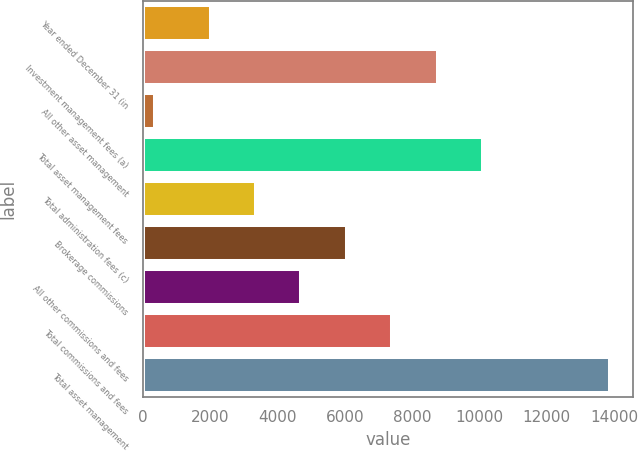<chart> <loc_0><loc_0><loc_500><loc_500><bar_chart><fcel>Year ended December 31 (in<fcel>Investment management fees (a)<fcel>All other asset management<fcel>Total asset management fees<fcel>Total administration fees (c)<fcel>Brokerage commissions<fcel>All other commissions and fees<fcel>Total commissions and fees<fcel>Total asset management<nl><fcel>2012<fcel>8767.5<fcel>357<fcel>10118.6<fcel>3363.1<fcel>6065.3<fcel>4714.2<fcel>7416.4<fcel>13868<nl></chart> 